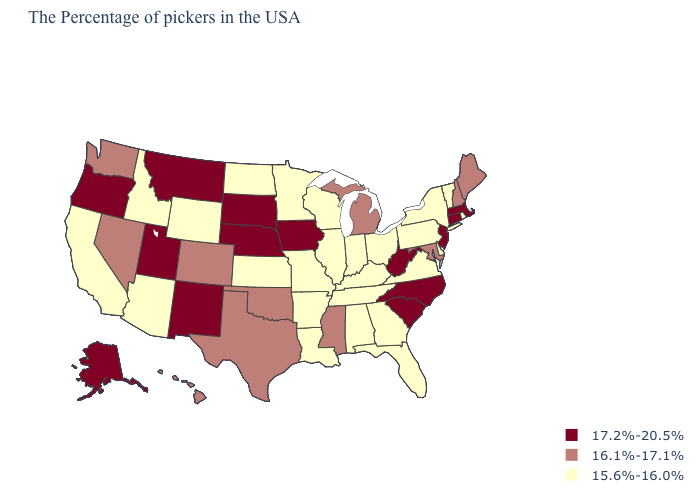Does South Carolina have the highest value in the South?
Give a very brief answer. Yes. Is the legend a continuous bar?
Answer briefly. No. Name the states that have a value in the range 16.1%-17.1%?
Give a very brief answer. Maine, New Hampshire, Maryland, Michigan, Mississippi, Oklahoma, Texas, Colorado, Nevada, Washington, Hawaii. Is the legend a continuous bar?
Concise answer only. No. Which states have the highest value in the USA?
Answer briefly. Massachusetts, Connecticut, New Jersey, North Carolina, South Carolina, West Virginia, Iowa, Nebraska, South Dakota, New Mexico, Utah, Montana, Oregon, Alaska. Among the states that border Delaware , does New Jersey have the highest value?
Keep it brief. Yes. Does the map have missing data?
Write a very short answer. No. Does Kentucky have the same value as Kansas?
Give a very brief answer. Yes. Which states have the lowest value in the West?
Short answer required. Wyoming, Arizona, Idaho, California. Does Pennsylvania have the highest value in the USA?
Keep it brief. No. Name the states that have a value in the range 16.1%-17.1%?
Quick response, please. Maine, New Hampshire, Maryland, Michigan, Mississippi, Oklahoma, Texas, Colorado, Nevada, Washington, Hawaii. Does Massachusetts have the lowest value in the USA?
Write a very short answer. No. Name the states that have a value in the range 16.1%-17.1%?
Answer briefly. Maine, New Hampshire, Maryland, Michigan, Mississippi, Oklahoma, Texas, Colorado, Nevada, Washington, Hawaii. Does South Carolina have the highest value in the USA?
Short answer required. Yes. Name the states that have a value in the range 17.2%-20.5%?
Write a very short answer. Massachusetts, Connecticut, New Jersey, North Carolina, South Carolina, West Virginia, Iowa, Nebraska, South Dakota, New Mexico, Utah, Montana, Oregon, Alaska. 